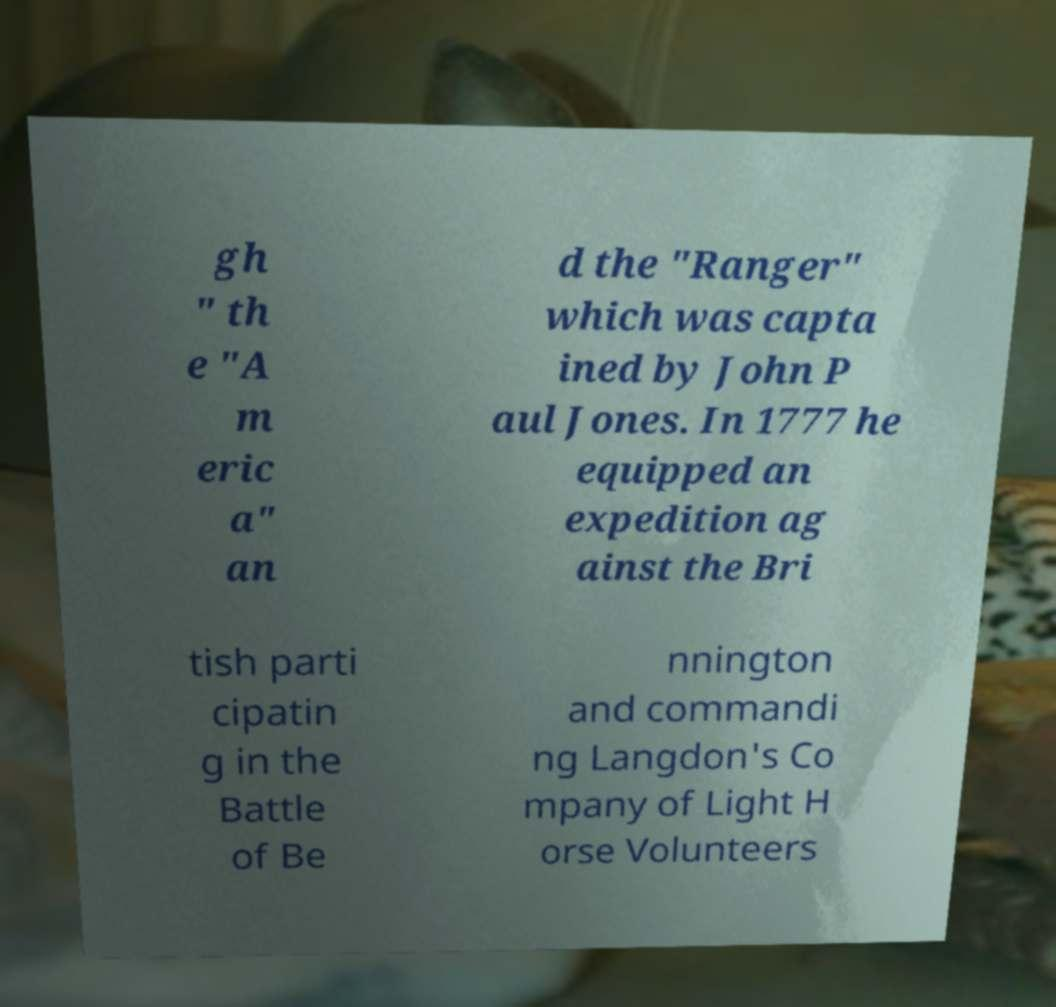I need the written content from this picture converted into text. Can you do that? gh " th e "A m eric a" an d the "Ranger" which was capta ined by John P aul Jones. In 1777 he equipped an expedition ag ainst the Bri tish parti cipatin g in the Battle of Be nnington and commandi ng Langdon's Co mpany of Light H orse Volunteers 